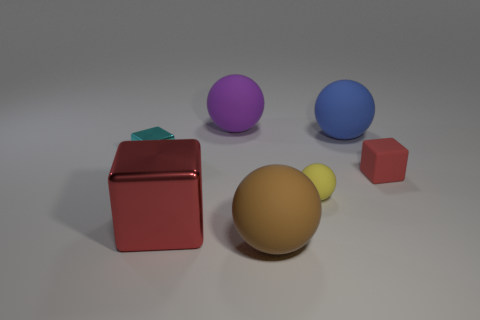Is the number of big blue spheres that are in front of the big blue thing the same as the number of small yellow rubber things to the right of the large brown rubber thing?
Your response must be concise. No. How many other things are there of the same material as the small yellow sphere?
Ensure brevity in your answer.  4. What number of metal things are either tiny cyan balls or yellow balls?
Your response must be concise. 0. There is a small yellow thing that is on the left side of the blue sphere; does it have the same shape as the tiny red thing?
Your answer should be very brief. No. Is the number of big blue rubber things in front of the large blue matte ball greater than the number of small cyan things?
Keep it short and to the point. No. How many big matte balls are behind the blue matte ball and in front of the yellow thing?
Provide a succinct answer. 0. What color is the big rubber object that is to the left of the big matte sphere in front of the small rubber cube?
Ensure brevity in your answer.  Purple. What number of big shiny cubes are the same color as the matte block?
Offer a terse response. 1. Does the big metallic thing have the same color as the cube that is on the right side of the purple thing?
Provide a short and direct response. Yes. Are there fewer tiny purple shiny cubes than big things?
Your response must be concise. Yes. 